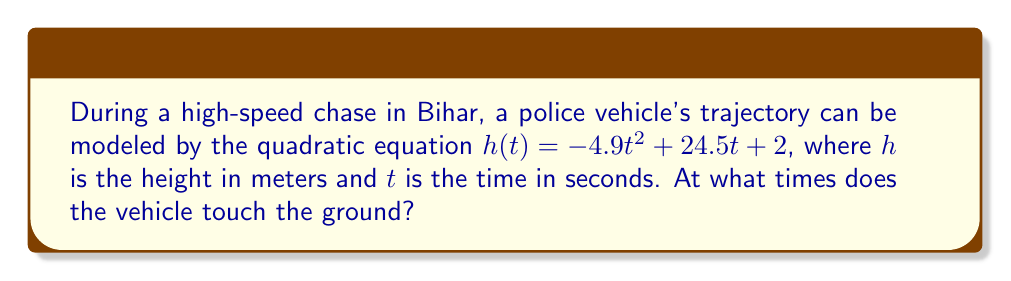Teach me how to tackle this problem. To find when the vehicle touches the ground, we need to solve the equation $h(t) = 0$:

1) Set up the equation:
   $-4.9t^2 + 24.5t + 2 = 0$

2) This is a quadratic equation in the form $at^2 + bt + c = 0$, where:
   $a = -4.9$, $b = 24.5$, and $c = 2$

3) We can solve this using the quadratic formula: $t = \frac{-b \pm \sqrt{b^2 - 4ac}}{2a}$

4) Substituting the values:
   $t = \frac{-24.5 \pm \sqrt{24.5^2 - 4(-4.9)(2)}}{2(-4.9)}$

5) Simplify under the square root:
   $t = \frac{-24.5 \pm \sqrt{600.25 + 39.2}}{-9.8}$
   $t = \frac{-24.5 \pm \sqrt{639.45}}{-9.8}$

6) Calculate the square root:
   $t = \frac{-24.5 \pm 25.29}{-9.8}$

7) Solve for both cases:
   $t_1 = \frac{-24.5 + 25.29}{-9.8} \approx 0.08$ seconds
   $t_2 = \frac{-24.5 - 25.29}{-9.8} \approx 5.08$ seconds

The vehicle touches the ground at approximately 0.08 seconds and 5.08 seconds.
Answer: $t \approx 0.08$ s and $t \approx 5.08$ s 